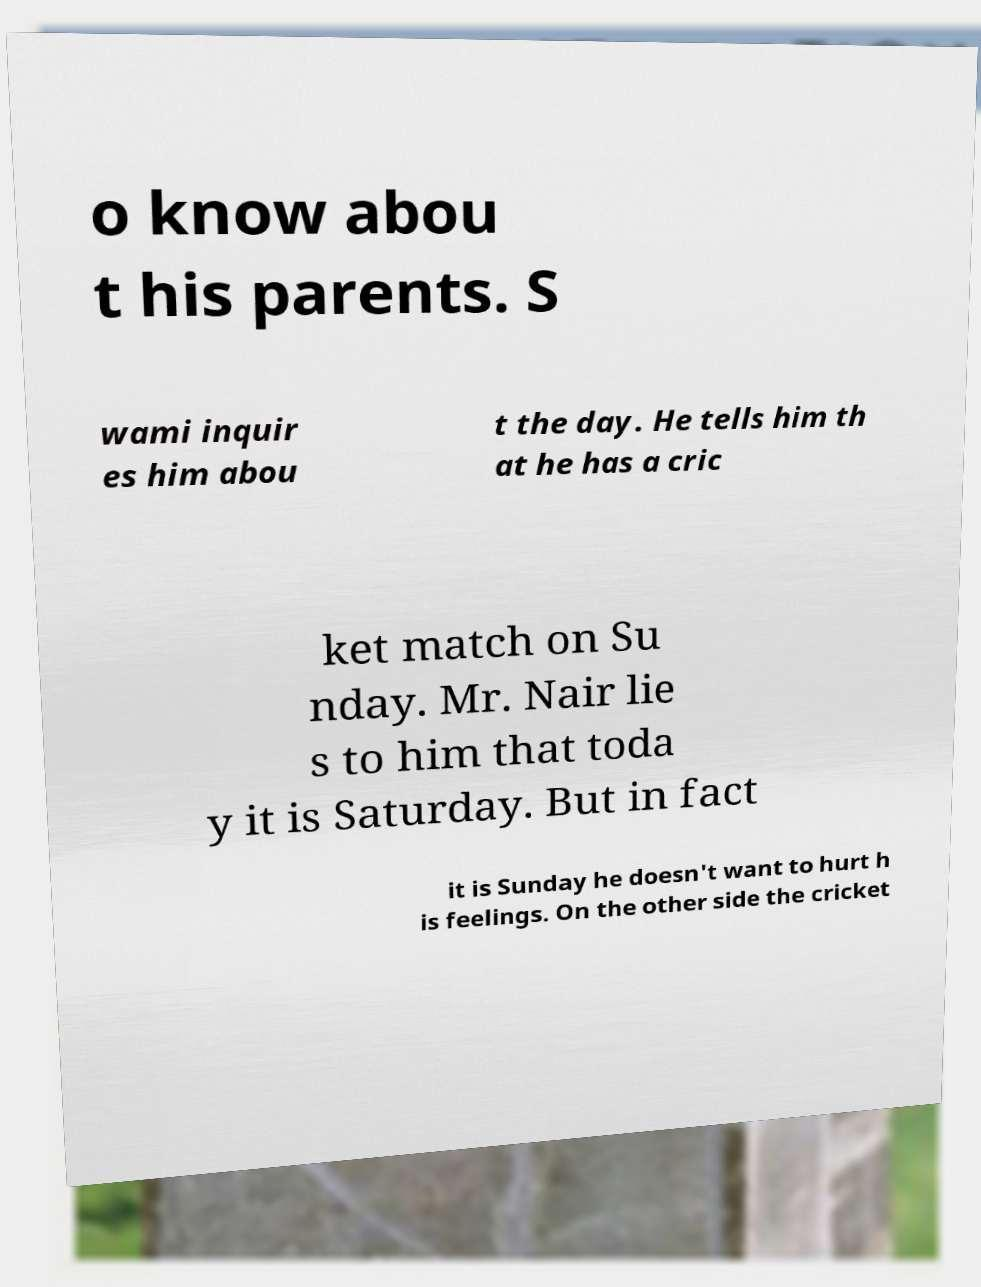What messages or text are displayed in this image? I need them in a readable, typed format. o know abou t his parents. S wami inquir es him abou t the day. He tells him th at he has a cric ket match on Su nday. Mr. Nair lie s to him that toda y it is Saturday. But in fact it is Sunday he doesn't want to hurt h is feelings. On the other side the cricket 